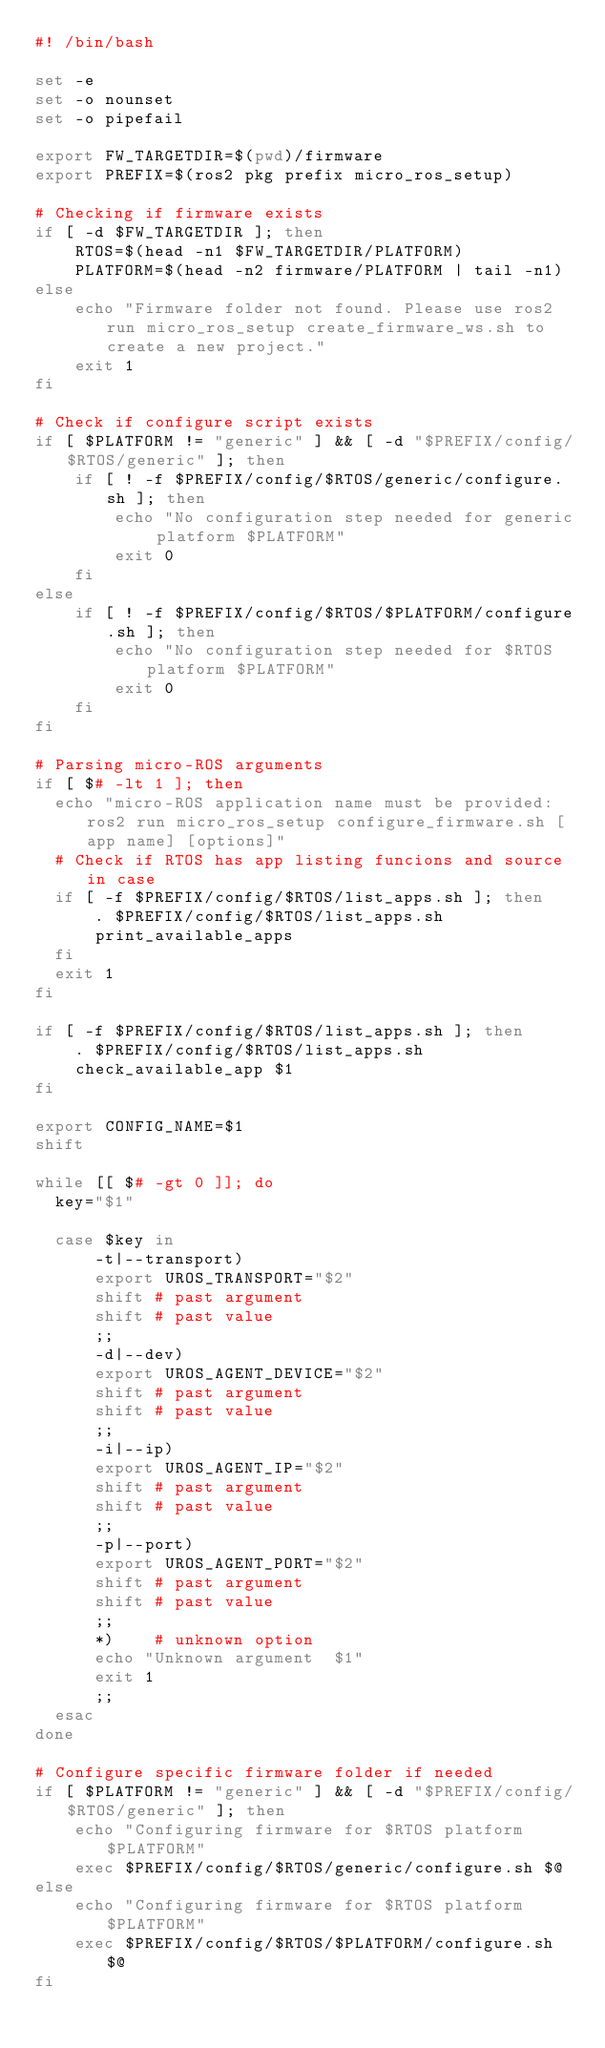Convert code to text. <code><loc_0><loc_0><loc_500><loc_500><_Bash_>#! /bin/bash 

set -e
set -o nounset
set -o pipefail

export FW_TARGETDIR=$(pwd)/firmware
export PREFIX=$(ros2 pkg prefix micro_ros_setup)

# Checking if firmware exists
if [ -d $FW_TARGETDIR ]; then
    RTOS=$(head -n1 $FW_TARGETDIR/PLATFORM)
    PLATFORM=$(head -n2 firmware/PLATFORM | tail -n1)
else
    echo "Firmware folder not found. Please use ros2 run micro_ros_setup create_firmware_ws.sh to create a new project."
    exit 1
fi

# Check if configure script exists
if [ $PLATFORM != "generic" ] && [ -d "$PREFIX/config/$RTOS/generic" ]; then
    if [ ! -f $PREFIX/config/$RTOS/generic/configure.sh ]; then
        echo "No configuration step needed for generic platform $PLATFORM"
        exit 0
    fi
else
    if [ ! -f $PREFIX/config/$RTOS/$PLATFORM/configure.sh ]; then
        echo "No configuration step needed for $RTOS platform $PLATFORM"
        exit 0
    fi
fi

# Parsing micro-ROS arguments
if [ $# -lt 1 ]; then
  echo "micro-ROS application name must be provided: ros2 run micro_ros_setup configure_firmware.sh [app name] [options]"
  # Check if RTOS has app listing funcions and source in case 
  if [ -f $PREFIX/config/$RTOS/list_apps.sh ]; then
      . $PREFIX/config/$RTOS/list_apps.sh
      print_available_apps
  fi
  exit 1
fi

if [ -f $PREFIX/config/$RTOS/list_apps.sh ]; then
    . $PREFIX/config/$RTOS/list_apps.sh
    check_available_app $1
fi

export CONFIG_NAME=$1
shift

while [[ $# -gt 0 ]]; do
  key="$1"

  case $key in
      -t|--transport)
      export UROS_TRANSPORT="$2"
      shift # past argument
      shift # past value
      ;;
      -d|--dev)
      export UROS_AGENT_DEVICE="$2"
      shift # past argument
      shift # past value
      ;;
      -i|--ip)
      export UROS_AGENT_IP="$2"
      shift # past argument
      shift # past value
      ;;
      -p|--port)
      export UROS_AGENT_PORT="$2"
      shift # past argument
      shift # past value
      ;;
      *)    # unknown option
      echo "Unknown argument  $1"
      exit 1
      ;;
  esac
done

# Configure specific firmware folder if needed
if [ $PLATFORM != "generic" ] && [ -d "$PREFIX/config/$RTOS/generic" ]; then
    echo "Configuring firmware for $RTOS platform $PLATFORM"
    exec $PREFIX/config/$RTOS/generic/configure.sh $@
else
    echo "Configuring firmware for $RTOS platform $PLATFORM"
    exec $PREFIX/config/$RTOS/$PLATFORM/configure.sh $@
fi

</code> 